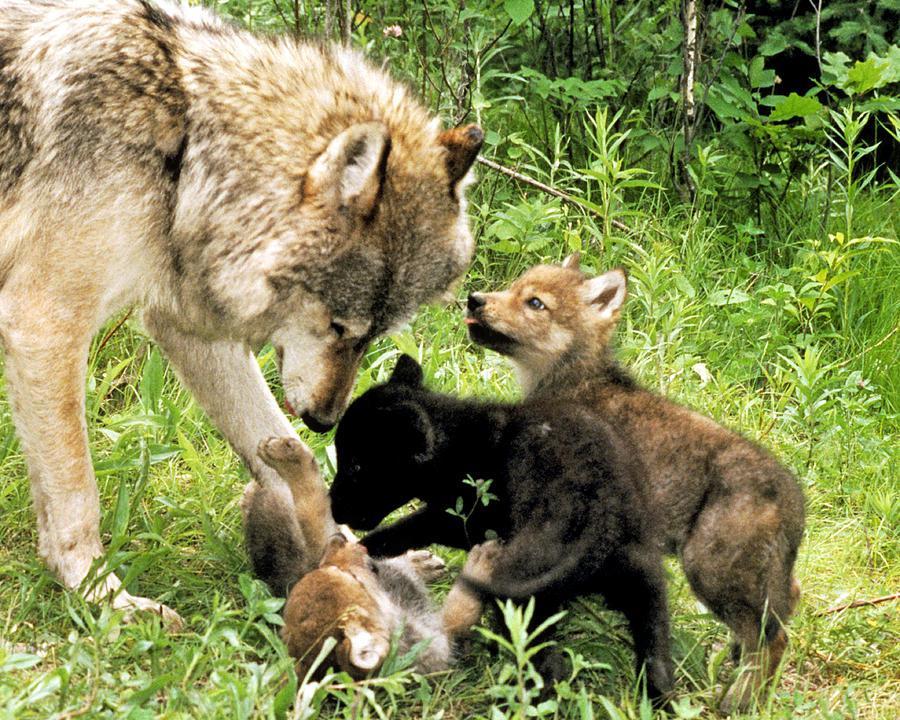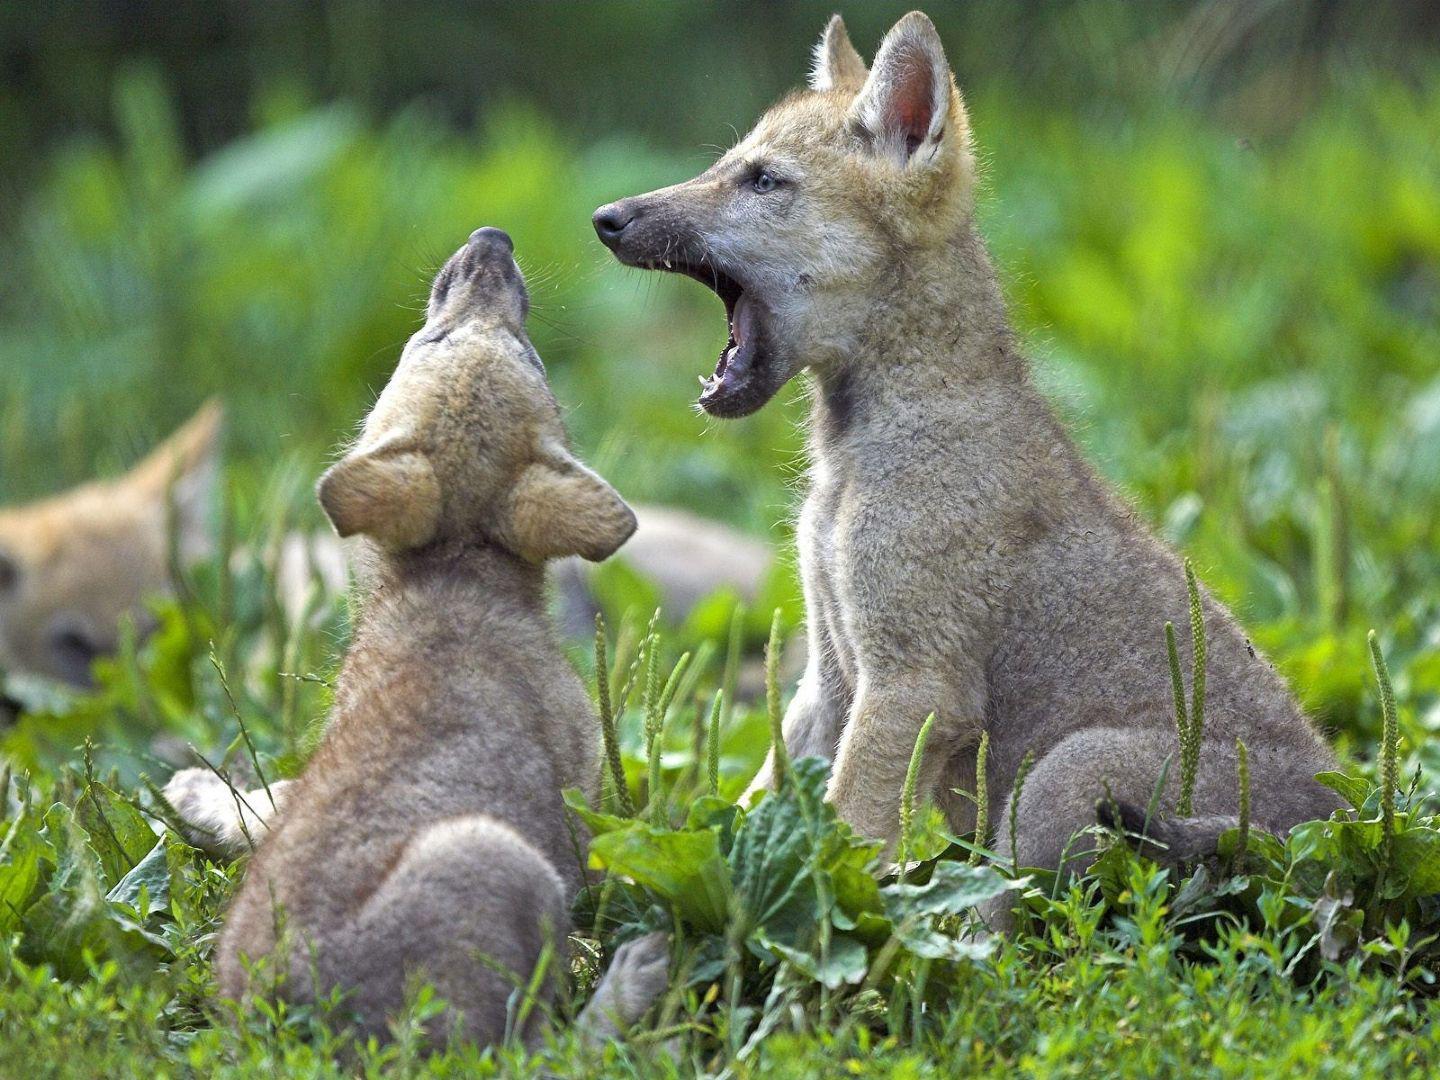The first image is the image on the left, the second image is the image on the right. Analyze the images presented: Is the assertion "One image shows no adult wolves, and the other image shows a standing adult wolf with multiple pups." valid? Answer yes or no. Yes. The first image is the image on the left, the second image is the image on the right. Examine the images to the left and right. Is the description "Several pups are nursing in the image on the left." accurate? Answer yes or no. No. 